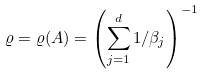Convert formula to latex. <formula><loc_0><loc_0><loc_500><loc_500>\varrho = \varrho ( A ) = \left ( \sum _ { j = 1 } ^ { d } 1 / \beta _ { j } \right ) ^ { - 1 }</formula> 